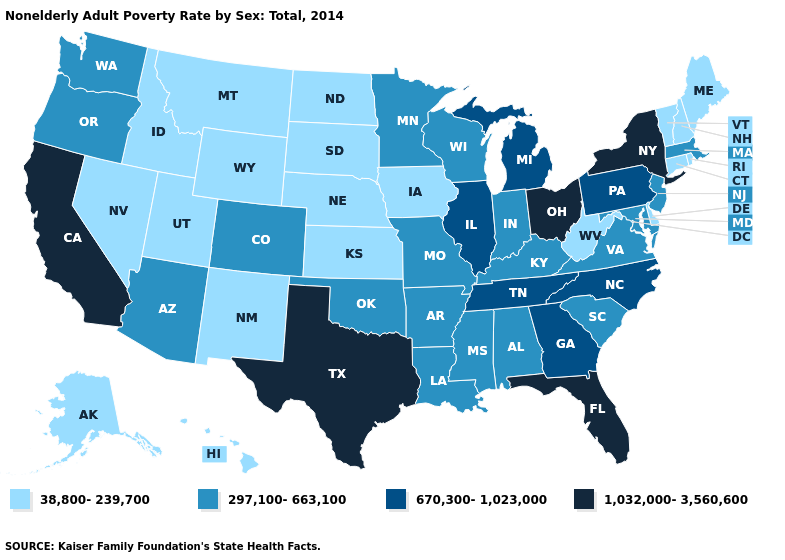Name the states that have a value in the range 38,800-239,700?
Concise answer only. Alaska, Connecticut, Delaware, Hawaii, Idaho, Iowa, Kansas, Maine, Montana, Nebraska, Nevada, New Hampshire, New Mexico, North Dakota, Rhode Island, South Dakota, Utah, Vermont, West Virginia, Wyoming. Does Massachusetts have the highest value in the USA?
Answer briefly. No. What is the highest value in the Northeast ?
Write a very short answer. 1,032,000-3,560,600. How many symbols are there in the legend?
Answer briefly. 4. What is the value of Connecticut?
Concise answer only. 38,800-239,700. What is the highest value in states that border Colorado?
Give a very brief answer. 297,100-663,100. What is the highest value in states that border New Mexico?
Quick response, please. 1,032,000-3,560,600. Name the states that have a value in the range 1,032,000-3,560,600?
Short answer required. California, Florida, New York, Ohio, Texas. What is the value of Kentucky?
Quick response, please. 297,100-663,100. Does Utah have a higher value than Virginia?
Short answer required. No. What is the highest value in states that border Delaware?
Short answer required. 670,300-1,023,000. Does New Hampshire have a lower value than Oklahoma?
Write a very short answer. Yes. Does Montana have the lowest value in the USA?
Answer briefly. Yes. Among the states that border Wyoming , does Colorado have the highest value?
Short answer required. Yes. Is the legend a continuous bar?
Keep it brief. No. 